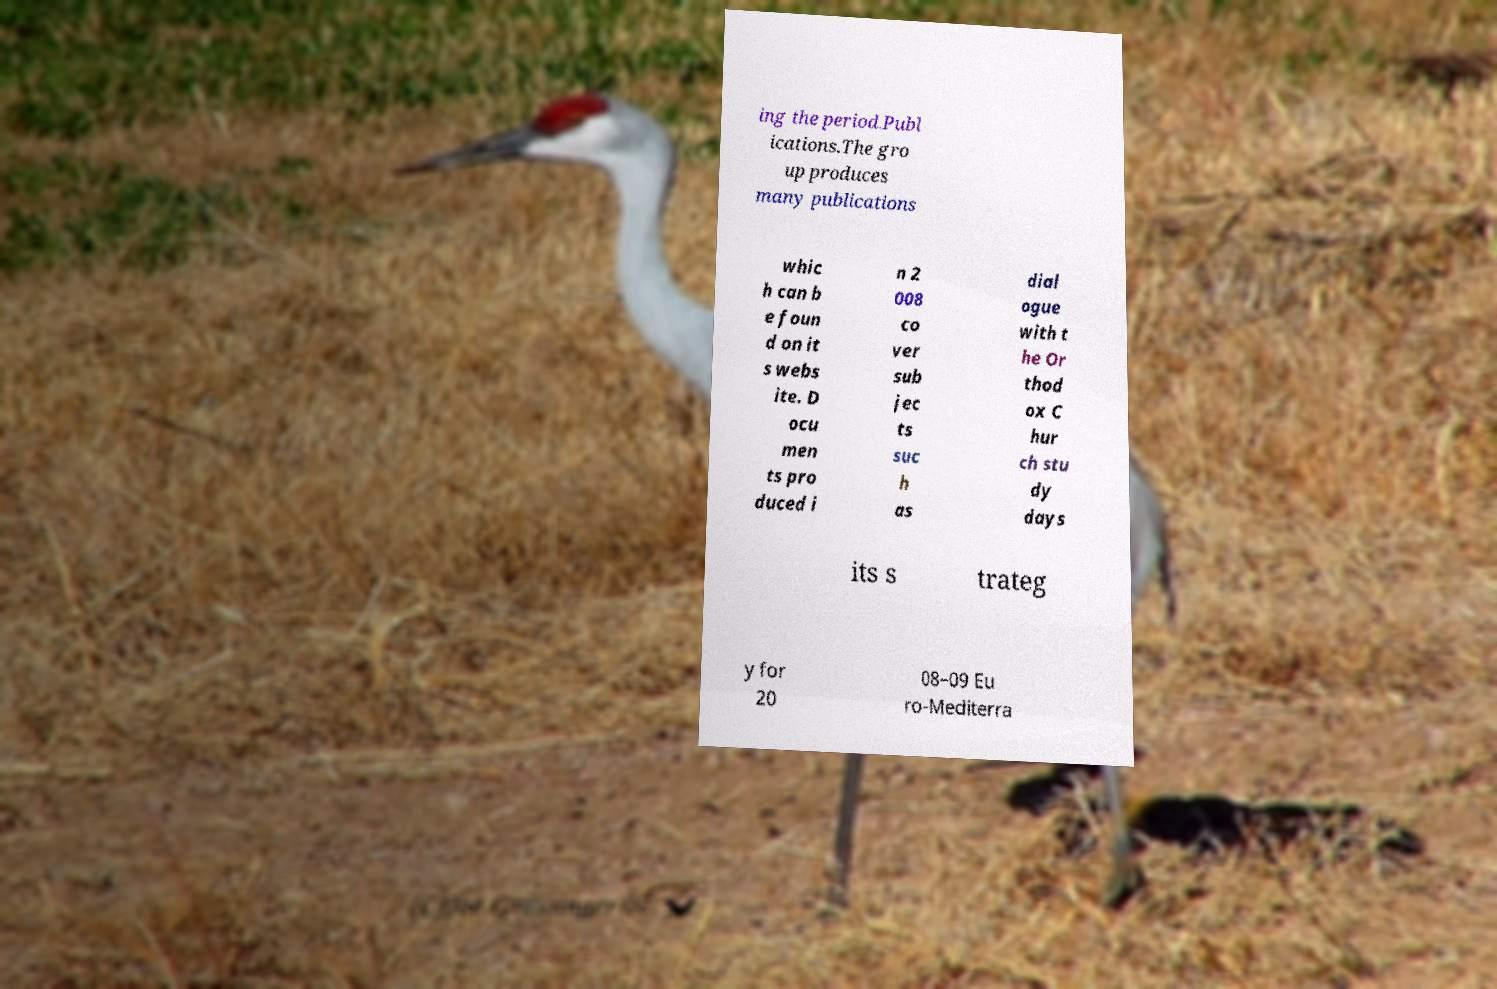What messages or text are displayed in this image? I need them in a readable, typed format. ing the period.Publ ications.The gro up produces many publications whic h can b e foun d on it s webs ite. D ocu men ts pro duced i n 2 008 co ver sub jec ts suc h as dial ogue with t he Or thod ox C hur ch stu dy days its s trateg y for 20 08–09 Eu ro-Mediterra 